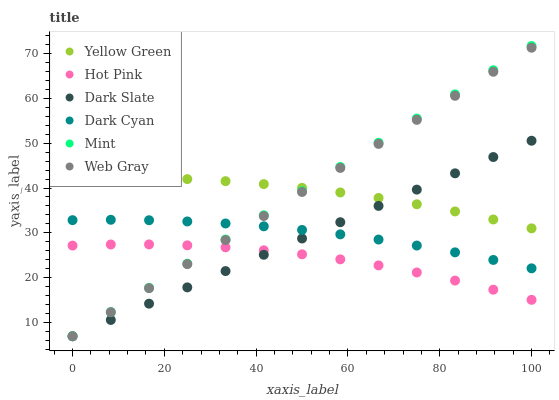Does Hot Pink have the minimum area under the curve?
Answer yes or no. Yes. Does Mint have the maximum area under the curve?
Answer yes or no. Yes. Does Yellow Green have the minimum area under the curve?
Answer yes or no. No. Does Yellow Green have the maximum area under the curve?
Answer yes or no. No. Is Web Gray the smoothest?
Answer yes or no. Yes. Is Hot Pink the roughest?
Answer yes or no. Yes. Is Yellow Green the smoothest?
Answer yes or no. No. Is Yellow Green the roughest?
Answer yes or no. No. Does Web Gray have the lowest value?
Answer yes or no. Yes. Does Hot Pink have the lowest value?
Answer yes or no. No. Does Mint have the highest value?
Answer yes or no. Yes. Does Yellow Green have the highest value?
Answer yes or no. No. Is Dark Cyan less than Yellow Green?
Answer yes or no. Yes. Is Dark Cyan greater than Hot Pink?
Answer yes or no. Yes. Does Web Gray intersect Mint?
Answer yes or no. Yes. Is Web Gray less than Mint?
Answer yes or no. No. Is Web Gray greater than Mint?
Answer yes or no. No. Does Dark Cyan intersect Yellow Green?
Answer yes or no. No. 